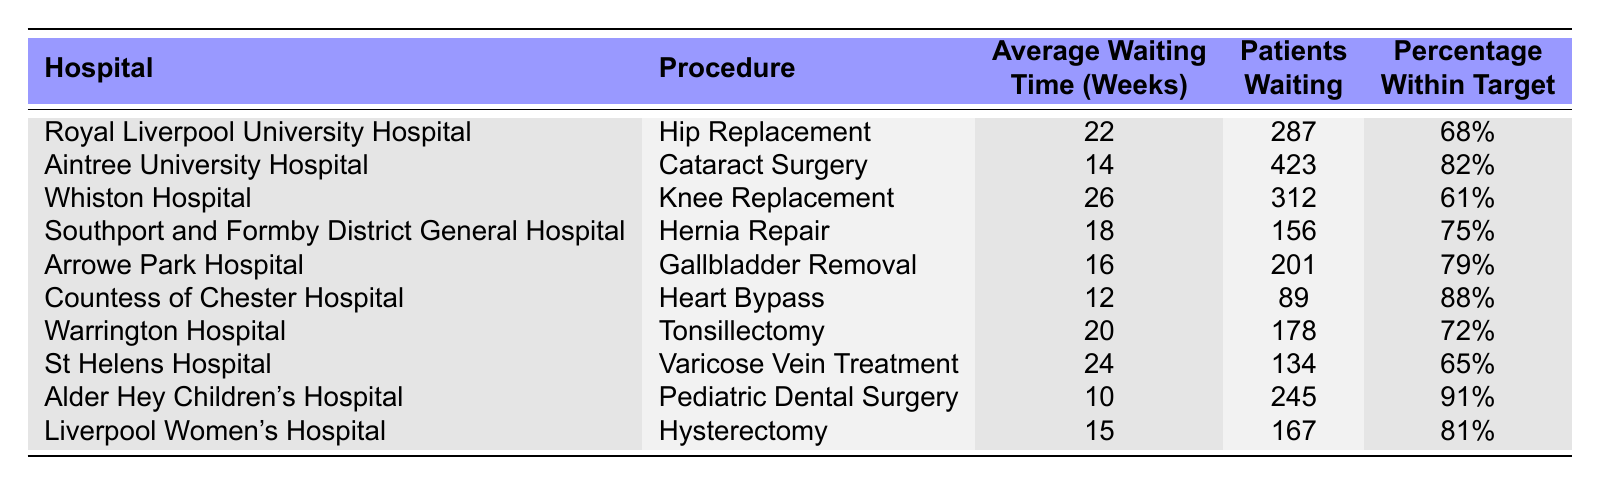What is the average waiting time for a hip replacement at Royal Liverpool University Hospital? The table lists the average waiting time for a hip replacement at Royal Liverpool University Hospital as 22 weeks.
Answer: 22 weeks Which procedure has the shortest waiting time, and how long is it? Looking at the average waiting times for all procedures, Pediatric Dental Surgery at Alder Hey Children's Hospital has the shortest waiting time, which is 10 weeks.
Answer: Pediatric Dental Surgery, 10 weeks How many patients are waiting for knee replacement at Whiston Hospital? According to the table, there are 312 patients waiting for a knee replacement at Whiston Hospital.
Answer: 312 patients What percentage of patients is within target for cataract surgery at Aintree University Hospital? The table indicates that 82% of patients are within target for cataract surgery at Aintree University Hospital.
Answer: 82% Which hospital has the highest average waiting time, and what is that time? Reviewing the average waiting times, Whiston Hospital has the highest average at 26 weeks for knee replacement.
Answer: Whiston Hospital, 26 weeks Calculate the total number of patients waiting across all hospitals for hip replacement and knee replacement. For hip replacement, there are 287 patients at Royal Liverpool University Hospital, and for knee replacement, 312 patients at Whiston Hospital. Adding them: 287 + 312 = 599.
Answer: 599 patients Is the percentage of patients within target for Heart Bypass at Countess of Chester Hospital above 80%? The table shows that 88% of patients are within target for Heart Bypass at Countess of Chester Hospital, which is above 80%.
Answer: Yes What is the difference in average waiting time between the longest (Knee Replacement) and shortest (Pediatric Dental Surgery) procedures? Knee Replacement has an average waiting time of 26 weeks and Pediatric Dental Surgery has 10 weeks. Subtracting gives 26 - 10 = 16 weeks.
Answer: 16 weeks Which procedure has a higher patient count: Tonsillectomy or Hernia Repair? Tonsillectomy has 178 patients while Hernia Repair has 156 patients. Since 178 is greater than 156, Tonsillectomy has a higher count.
Answer: Tonsillectomy Are the average waiting times for Hernia Repair and Gallbladder Removal both below 20 weeks? Hernia Repair has an average waiting time of 18 weeks and Gallbladder Removal has 16 weeks. Both are below 20 weeks.
Answer: Yes 